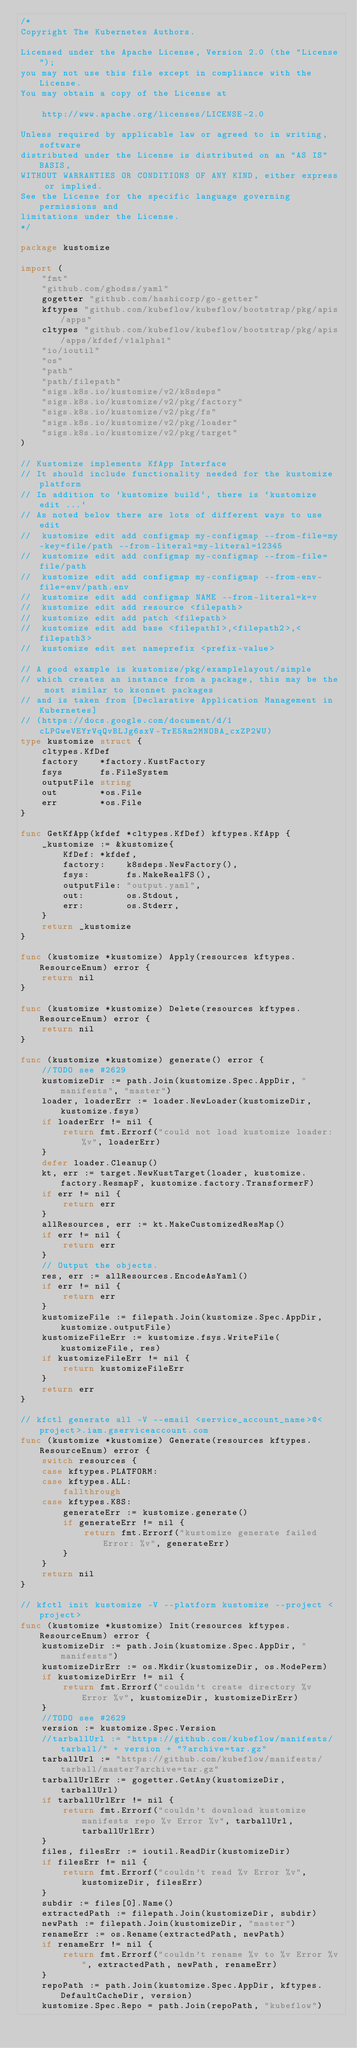Convert code to text. <code><loc_0><loc_0><loc_500><loc_500><_Go_>/*
Copyright The Kubernetes Authors.

Licensed under the Apache License, Version 2.0 (the "License");
you may not use this file except in compliance with the License.
You may obtain a copy of the License at

    http://www.apache.org/licenses/LICENSE-2.0

Unless required by applicable law or agreed to in writing, software
distributed under the License is distributed on an "AS IS" BASIS,
WITHOUT WARRANTIES OR CONDITIONS OF ANY KIND, either express or implied.
See the License for the specific language governing permissions and
limitations under the License.
*/

package kustomize

import (
	"fmt"
	"github.com/ghodss/yaml"
	gogetter "github.com/hashicorp/go-getter"
	kftypes "github.com/kubeflow/kubeflow/bootstrap/pkg/apis/apps"
	cltypes "github.com/kubeflow/kubeflow/bootstrap/pkg/apis/apps/kfdef/v1alpha1"
	"io/ioutil"
	"os"
	"path"
	"path/filepath"
	"sigs.k8s.io/kustomize/v2/k8sdeps"
	"sigs.k8s.io/kustomize/v2/pkg/factory"
	"sigs.k8s.io/kustomize/v2/pkg/fs"
	"sigs.k8s.io/kustomize/v2/pkg/loader"
	"sigs.k8s.io/kustomize/v2/pkg/target"
)

// Kustomize implements KfApp Interface
// It should include functionality needed for the kustomize platform
// In addition to `kustomize build`, there is `kustomize edit ...`
// As noted below there are lots of different ways to use edit
//  kustomize edit add configmap my-configmap --from-file=my-key=file/path --from-literal=my-literal=12345
//  kustomize edit add configmap my-configmap --from-file=file/path
//  kustomize edit add configmap my-configmap --from-env-file=env/path.env
//  kustomize edit add configmap NAME --from-literal=k=v
//  kustomize edit add resource <filepath>
//  kustomize edit add patch <filepath>
//  kustomize edit add base <filepath1>,<filepath2>,<filepath3>
//  kustomize edit set nameprefix <prefix-value>

// A good example is kustomize/pkg/examplelayout/simple
// which creates an instance from a package, this may be the most similar to ksonnet packages
// and is taken from [Declarative Application Management in Kubernetes]
// (https://docs.google.com/document/d/1cLPGweVEYrVqQvBLJg6sxV-TrE5Rm2MNOBA_cxZP2WU)
type kustomize struct {
	cltypes.KfDef
	factory    *factory.KustFactory
	fsys       fs.FileSystem
	outputFile string
	out        *os.File
	err        *os.File
}

func GetKfApp(kfdef *cltypes.KfDef) kftypes.KfApp {
	_kustomize := &kustomize{
		KfDef: *kfdef,
		factory:    k8sdeps.NewFactory(),
		fsys:       fs.MakeRealFS(),
		outputFile: "output.yaml",
		out:        os.Stdout,
		err:        os.Stderr,
	}
	return _kustomize
}

func (kustomize *kustomize) Apply(resources kftypes.ResourceEnum) error {
	return nil
}

func (kustomize *kustomize) Delete(resources kftypes.ResourceEnum) error {
	return nil
}

func (kustomize *kustomize) generate() error {
	//TODO see #2629
	kustomizeDir := path.Join(kustomize.Spec.AppDir, "manifests", "master")
	loader, loaderErr := loader.NewLoader(kustomizeDir, kustomize.fsys)
	if loaderErr != nil {
		return fmt.Errorf("could not load kustomize loader: %v", loaderErr)
	}
	defer loader.Cleanup()
	kt, err := target.NewKustTarget(loader, kustomize.factory.ResmapF, kustomize.factory.TransformerF)
	if err != nil {
		return err
	}
	allResources, err := kt.MakeCustomizedResMap()
	if err != nil {
		return err
	}
	// Output the objects.
	res, err := allResources.EncodeAsYaml()
	if err != nil {
		return err
	}
	kustomizeFile := filepath.Join(kustomize.Spec.AppDir, kustomize.outputFile)
	kustomizeFileErr := kustomize.fsys.WriteFile(kustomizeFile, res)
	if kustomizeFileErr != nil {
		return kustomizeFileErr
	}
	return err
}

// kfctl generate all -V --email <service_account_name>@<project>.iam.gserviceaccount.com
func (kustomize *kustomize) Generate(resources kftypes.ResourceEnum) error {
	switch resources {
	case kftypes.PLATFORM:
	case kftypes.ALL:
		fallthrough
	case kftypes.K8S:
		generateErr := kustomize.generate()
		if generateErr != nil {
			return fmt.Errorf("kustomize generate failed Error: %v", generateErr)
		}
	}
	return nil
}

// kfctl init kustomize -V --platform kustomize --project <project>
func (kustomize *kustomize) Init(resources kftypes.ResourceEnum) error {
	kustomizeDir := path.Join(kustomize.Spec.AppDir, "manifests")
	kustomizeDirErr := os.Mkdir(kustomizeDir, os.ModePerm)
	if kustomizeDirErr != nil {
		return fmt.Errorf("couldn't create directory %v Error %v", kustomizeDir, kustomizeDirErr)
	}
	//TODO see #2629
	version := kustomize.Spec.Version
	//tarballUrl := "https://github.com/kubeflow/manifests/tarball/" + version + "?archive=tar.gz"
	tarballUrl := "https://github.com/kubeflow/manifests/tarball/master?archive=tar.gz"
	tarballUrlErr := gogetter.GetAny(kustomizeDir, tarballUrl)
	if tarballUrlErr != nil {
		return fmt.Errorf("couldn't download kustomize manifests repo %v Error %v", tarballUrl, tarballUrlErr)
	}
	files, filesErr := ioutil.ReadDir(kustomizeDir)
	if filesErr != nil {
		return fmt.Errorf("couldn't read %v Error %v", kustomizeDir, filesErr)
	}
	subdir := files[0].Name()
	extractedPath := filepath.Join(kustomizeDir, subdir)
	newPath := filepath.Join(kustomizeDir, "master")
	renameErr := os.Rename(extractedPath, newPath)
	if renameErr != nil {
		return fmt.Errorf("couldn't rename %v to %v Error %v", extractedPath, newPath, renameErr)
	}
	repoPath := path.Join(kustomize.Spec.AppDir, kftypes.DefaultCacheDir, version)
	kustomize.Spec.Repo = path.Join(repoPath, "kubeflow")</code> 